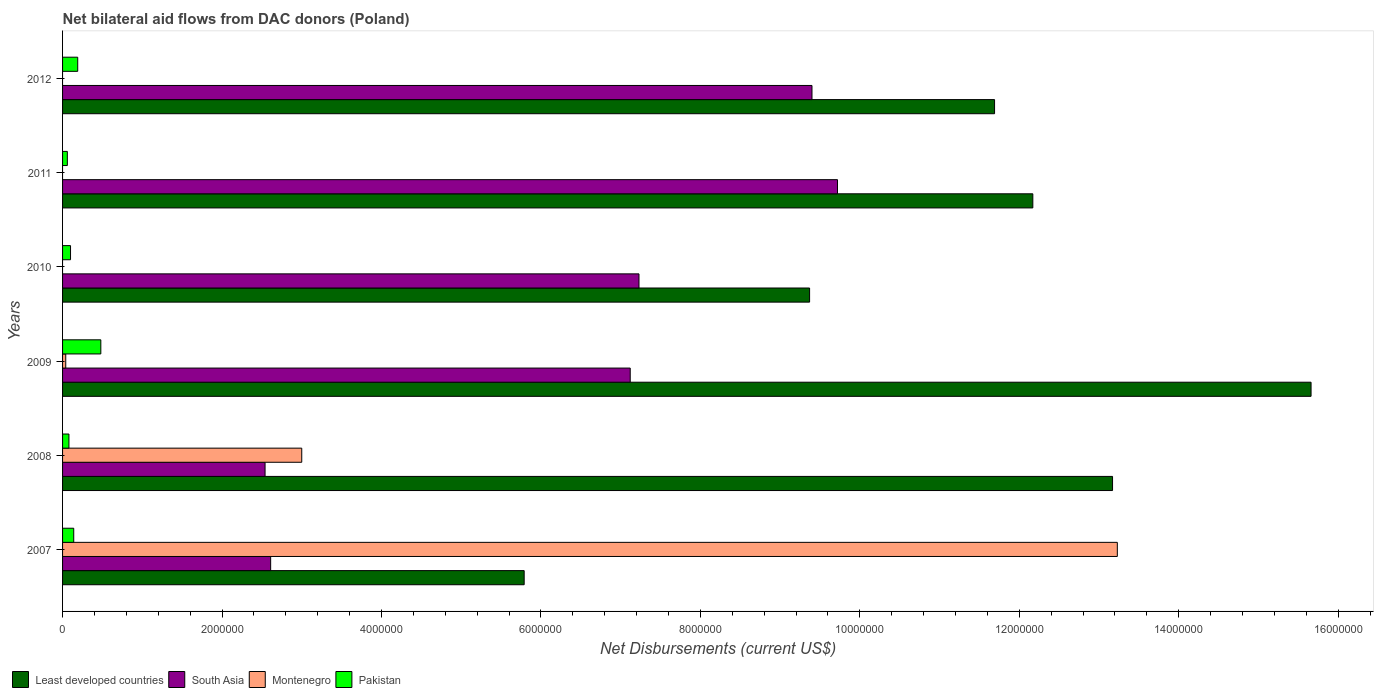Are the number of bars per tick equal to the number of legend labels?
Offer a terse response. No. Are the number of bars on each tick of the Y-axis equal?
Your response must be concise. No. How many bars are there on the 5th tick from the bottom?
Offer a terse response. 3. What is the net bilateral aid flows in Least developed countries in 2010?
Offer a terse response. 9.37e+06. Across all years, what is the maximum net bilateral aid flows in South Asia?
Make the answer very short. 9.72e+06. What is the total net bilateral aid flows in Pakistan in the graph?
Your answer should be very brief. 1.05e+06. What is the difference between the net bilateral aid flows in Least developed countries in 2008 and that in 2009?
Offer a terse response. -2.49e+06. What is the difference between the net bilateral aid flows in Montenegro in 2011 and the net bilateral aid flows in Pakistan in 2012?
Your answer should be compact. -1.90e+05. What is the average net bilateral aid flows in Montenegro per year?
Give a very brief answer. 2.71e+06. In the year 2008, what is the difference between the net bilateral aid flows in Pakistan and net bilateral aid flows in South Asia?
Give a very brief answer. -2.46e+06. Is the difference between the net bilateral aid flows in Pakistan in 2008 and 2009 greater than the difference between the net bilateral aid flows in South Asia in 2008 and 2009?
Ensure brevity in your answer.  Yes. What is the difference between the highest and the second highest net bilateral aid flows in Least developed countries?
Keep it short and to the point. 2.49e+06. What is the difference between the highest and the lowest net bilateral aid flows in Pakistan?
Provide a succinct answer. 4.20e+05. In how many years, is the net bilateral aid flows in Least developed countries greater than the average net bilateral aid flows in Least developed countries taken over all years?
Ensure brevity in your answer.  4. Is it the case that in every year, the sum of the net bilateral aid flows in Montenegro and net bilateral aid flows in Least developed countries is greater than the net bilateral aid flows in Pakistan?
Your answer should be compact. Yes. Are all the bars in the graph horizontal?
Give a very brief answer. Yes. How many years are there in the graph?
Your answer should be very brief. 6. What is the difference between two consecutive major ticks on the X-axis?
Your answer should be very brief. 2.00e+06. Are the values on the major ticks of X-axis written in scientific E-notation?
Ensure brevity in your answer.  No. Where does the legend appear in the graph?
Keep it short and to the point. Bottom left. How many legend labels are there?
Give a very brief answer. 4. What is the title of the graph?
Ensure brevity in your answer.  Net bilateral aid flows from DAC donors (Poland). What is the label or title of the X-axis?
Provide a succinct answer. Net Disbursements (current US$). What is the Net Disbursements (current US$) of Least developed countries in 2007?
Provide a short and direct response. 5.79e+06. What is the Net Disbursements (current US$) in South Asia in 2007?
Make the answer very short. 2.61e+06. What is the Net Disbursements (current US$) in Montenegro in 2007?
Your response must be concise. 1.32e+07. What is the Net Disbursements (current US$) of Pakistan in 2007?
Provide a short and direct response. 1.40e+05. What is the Net Disbursements (current US$) of Least developed countries in 2008?
Provide a short and direct response. 1.32e+07. What is the Net Disbursements (current US$) in South Asia in 2008?
Offer a very short reply. 2.54e+06. What is the Net Disbursements (current US$) in Least developed countries in 2009?
Provide a succinct answer. 1.57e+07. What is the Net Disbursements (current US$) in South Asia in 2009?
Keep it short and to the point. 7.12e+06. What is the Net Disbursements (current US$) of Least developed countries in 2010?
Keep it short and to the point. 9.37e+06. What is the Net Disbursements (current US$) of South Asia in 2010?
Keep it short and to the point. 7.23e+06. What is the Net Disbursements (current US$) in Montenegro in 2010?
Your response must be concise. 0. What is the Net Disbursements (current US$) in Pakistan in 2010?
Provide a succinct answer. 1.00e+05. What is the Net Disbursements (current US$) of Least developed countries in 2011?
Provide a short and direct response. 1.22e+07. What is the Net Disbursements (current US$) of South Asia in 2011?
Ensure brevity in your answer.  9.72e+06. What is the Net Disbursements (current US$) of Montenegro in 2011?
Provide a succinct answer. 0. What is the Net Disbursements (current US$) in Pakistan in 2011?
Provide a succinct answer. 6.00e+04. What is the Net Disbursements (current US$) of Least developed countries in 2012?
Keep it short and to the point. 1.17e+07. What is the Net Disbursements (current US$) in South Asia in 2012?
Your response must be concise. 9.40e+06. What is the Net Disbursements (current US$) in Montenegro in 2012?
Give a very brief answer. 0. Across all years, what is the maximum Net Disbursements (current US$) in Least developed countries?
Provide a succinct answer. 1.57e+07. Across all years, what is the maximum Net Disbursements (current US$) in South Asia?
Your response must be concise. 9.72e+06. Across all years, what is the maximum Net Disbursements (current US$) of Montenegro?
Offer a very short reply. 1.32e+07. Across all years, what is the maximum Net Disbursements (current US$) of Pakistan?
Your answer should be compact. 4.80e+05. Across all years, what is the minimum Net Disbursements (current US$) in Least developed countries?
Keep it short and to the point. 5.79e+06. Across all years, what is the minimum Net Disbursements (current US$) of South Asia?
Your answer should be very brief. 2.54e+06. Across all years, what is the minimum Net Disbursements (current US$) in Montenegro?
Make the answer very short. 0. What is the total Net Disbursements (current US$) of Least developed countries in the graph?
Your response must be concise. 6.78e+07. What is the total Net Disbursements (current US$) in South Asia in the graph?
Provide a short and direct response. 3.86e+07. What is the total Net Disbursements (current US$) of Montenegro in the graph?
Your answer should be compact. 1.63e+07. What is the total Net Disbursements (current US$) of Pakistan in the graph?
Your answer should be very brief. 1.05e+06. What is the difference between the Net Disbursements (current US$) of Least developed countries in 2007 and that in 2008?
Offer a very short reply. -7.38e+06. What is the difference between the Net Disbursements (current US$) of South Asia in 2007 and that in 2008?
Provide a succinct answer. 7.00e+04. What is the difference between the Net Disbursements (current US$) in Montenegro in 2007 and that in 2008?
Make the answer very short. 1.02e+07. What is the difference between the Net Disbursements (current US$) of Least developed countries in 2007 and that in 2009?
Provide a succinct answer. -9.87e+06. What is the difference between the Net Disbursements (current US$) in South Asia in 2007 and that in 2009?
Keep it short and to the point. -4.51e+06. What is the difference between the Net Disbursements (current US$) in Montenegro in 2007 and that in 2009?
Your answer should be very brief. 1.32e+07. What is the difference between the Net Disbursements (current US$) in Least developed countries in 2007 and that in 2010?
Your answer should be very brief. -3.58e+06. What is the difference between the Net Disbursements (current US$) of South Asia in 2007 and that in 2010?
Give a very brief answer. -4.62e+06. What is the difference between the Net Disbursements (current US$) in Pakistan in 2007 and that in 2010?
Provide a succinct answer. 4.00e+04. What is the difference between the Net Disbursements (current US$) in Least developed countries in 2007 and that in 2011?
Ensure brevity in your answer.  -6.38e+06. What is the difference between the Net Disbursements (current US$) in South Asia in 2007 and that in 2011?
Make the answer very short. -7.11e+06. What is the difference between the Net Disbursements (current US$) of Pakistan in 2007 and that in 2011?
Give a very brief answer. 8.00e+04. What is the difference between the Net Disbursements (current US$) of Least developed countries in 2007 and that in 2012?
Make the answer very short. -5.90e+06. What is the difference between the Net Disbursements (current US$) in South Asia in 2007 and that in 2012?
Ensure brevity in your answer.  -6.79e+06. What is the difference between the Net Disbursements (current US$) of Pakistan in 2007 and that in 2012?
Your answer should be very brief. -5.00e+04. What is the difference between the Net Disbursements (current US$) of Least developed countries in 2008 and that in 2009?
Your response must be concise. -2.49e+06. What is the difference between the Net Disbursements (current US$) of South Asia in 2008 and that in 2009?
Provide a succinct answer. -4.58e+06. What is the difference between the Net Disbursements (current US$) of Montenegro in 2008 and that in 2009?
Your response must be concise. 2.96e+06. What is the difference between the Net Disbursements (current US$) of Pakistan in 2008 and that in 2009?
Offer a very short reply. -4.00e+05. What is the difference between the Net Disbursements (current US$) of Least developed countries in 2008 and that in 2010?
Your response must be concise. 3.80e+06. What is the difference between the Net Disbursements (current US$) in South Asia in 2008 and that in 2010?
Make the answer very short. -4.69e+06. What is the difference between the Net Disbursements (current US$) of Least developed countries in 2008 and that in 2011?
Ensure brevity in your answer.  1.00e+06. What is the difference between the Net Disbursements (current US$) in South Asia in 2008 and that in 2011?
Make the answer very short. -7.18e+06. What is the difference between the Net Disbursements (current US$) in Pakistan in 2008 and that in 2011?
Offer a terse response. 2.00e+04. What is the difference between the Net Disbursements (current US$) in Least developed countries in 2008 and that in 2012?
Offer a terse response. 1.48e+06. What is the difference between the Net Disbursements (current US$) in South Asia in 2008 and that in 2012?
Offer a terse response. -6.86e+06. What is the difference between the Net Disbursements (current US$) in Least developed countries in 2009 and that in 2010?
Your answer should be compact. 6.29e+06. What is the difference between the Net Disbursements (current US$) in South Asia in 2009 and that in 2010?
Offer a very short reply. -1.10e+05. What is the difference between the Net Disbursements (current US$) in Pakistan in 2009 and that in 2010?
Offer a terse response. 3.80e+05. What is the difference between the Net Disbursements (current US$) of Least developed countries in 2009 and that in 2011?
Your answer should be compact. 3.49e+06. What is the difference between the Net Disbursements (current US$) in South Asia in 2009 and that in 2011?
Make the answer very short. -2.60e+06. What is the difference between the Net Disbursements (current US$) of Pakistan in 2009 and that in 2011?
Provide a succinct answer. 4.20e+05. What is the difference between the Net Disbursements (current US$) of Least developed countries in 2009 and that in 2012?
Make the answer very short. 3.97e+06. What is the difference between the Net Disbursements (current US$) of South Asia in 2009 and that in 2012?
Give a very brief answer. -2.28e+06. What is the difference between the Net Disbursements (current US$) in Least developed countries in 2010 and that in 2011?
Make the answer very short. -2.80e+06. What is the difference between the Net Disbursements (current US$) of South Asia in 2010 and that in 2011?
Give a very brief answer. -2.49e+06. What is the difference between the Net Disbursements (current US$) of Least developed countries in 2010 and that in 2012?
Offer a very short reply. -2.32e+06. What is the difference between the Net Disbursements (current US$) in South Asia in 2010 and that in 2012?
Make the answer very short. -2.17e+06. What is the difference between the Net Disbursements (current US$) of Pakistan in 2010 and that in 2012?
Provide a short and direct response. -9.00e+04. What is the difference between the Net Disbursements (current US$) of Least developed countries in 2011 and that in 2012?
Provide a short and direct response. 4.80e+05. What is the difference between the Net Disbursements (current US$) in South Asia in 2011 and that in 2012?
Make the answer very short. 3.20e+05. What is the difference between the Net Disbursements (current US$) of Least developed countries in 2007 and the Net Disbursements (current US$) of South Asia in 2008?
Your answer should be compact. 3.25e+06. What is the difference between the Net Disbursements (current US$) in Least developed countries in 2007 and the Net Disbursements (current US$) in Montenegro in 2008?
Keep it short and to the point. 2.79e+06. What is the difference between the Net Disbursements (current US$) in Least developed countries in 2007 and the Net Disbursements (current US$) in Pakistan in 2008?
Keep it short and to the point. 5.71e+06. What is the difference between the Net Disbursements (current US$) in South Asia in 2007 and the Net Disbursements (current US$) in Montenegro in 2008?
Make the answer very short. -3.90e+05. What is the difference between the Net Disbursements (current US$) of South Asia in 2007 and the Net Disbursements (current US$) of Pakistan in 2008?
Provide a succinct answer. 2.53e+06. What is the difference between the Net Disbursements (current US$) in Montenegro in 2007 and the Net Disbursements (current US$) in Pakistan in 2008?
Offer a very short reply. 1.32e+07. What is the difference between the Net Disbursements (current US$) in Least developed countries in 2007 and the Net Disbursements (current US$) in South Asia in 2009?
Provide a succinct answer. -1.33e+06. What is the difference between the Net Disbursements (current US$) in Least developed countries in 2007 and the Net Disbursements (current US$) in Montenegro in 2009?
Ensure brevity in your answer.  5.75e+06. What is the difference between the Net Disbursements (current US$) in Least developed countries in 2007 and the Net Disbursements (current US$) in Pakistan in 2009?
Ensure brevity in your answer.  5.31e+06. What is the difference between the Net Disbursements (current US$) of South Asia in 2007 and the Net Disbursements (current US$) of Montenegro in 2009?
Provide a short and direct response. 2.57e+06. What is the difference between the Net Disbursements (current US$) in South Asia in 2007 and the Net Disbursements (current US$) in Pakistan in 2009?
Give a very brief answer. 2.13e+06. What is the difference between the Net Disbursements (current US$) in Montenegro in 2007 and the Net Disbursements (current US$) in Pakistan in 2009?
Make the answer very short. 1.28e+07. What is the difference between the Net Disbursements (current US$) in Least developed countries in 2007 and the Net Disbursements (current US$) in South Asia in 2010?
Offer a terse response. -1.44e+06. What is the difference between the Net Disbursements (current US$) of Least developed countries in 2007 and the Net Disbursements (current US$) of Pakistan in 2010?
Keep it short and to the point. 5.69e+06. What is the difference between the Net Disbursements (current US$) in South Asia in 2007 and the Net Disbursements (current US$) in Pakistan in 2010?
Your answer should be very brief. 2.51e+06. What is the difference between the Net Disbursements (current US$) in Montenegro in 2007 and the Net Disbursements (current US$) in Pakistan in 2010?
Ensure brevity in your answer.  1.31e+07. What is the difference between the Net Disbursements (current US$) in Least developed countries in 2007 and the Net Disbursements (current US$) in South Asia in 2011?
Make the answer very short. -3.93e+06. What is the difference between the Net Disbursements (current US$) of Least developed countries in 2007 and the Net Disbursements (current US$) of Pakistan in 2011?
Offer a terse response. 5.73e+06. What is the difference between the Net Disbursements (current US$) in South Asia in 2007 and the Net Disbursements (current US$) in Pakistan in 2011?
Offer a terse response. 2.55e+06. What is the difference between the Net Disbursements (current US$) in Montenegro in 2007 and the Net Disbursements (current US$) in Pakistan in 2011?
Make the answer very short. 1.32e+07. What is the difference between the Net Disbursements (current US$) in Least developed countries in 2007 and the Net Disbursements (current US$) in South Asia in 2012?
Provide a short and direct response. -3.61e+06. What is the difference between the Net Disbursements (current US$) of Least developed countries in 2007 and the Net Disbursements (current US$) of Pakistan in 2012?
Ensure brevity in your answer.  5.60e+06. What is the difference between the Net Disbursements (current US$) of South Asia in 2007 and the Net Disbursements (current US$) of Pakistan in 2012?
Keep it short and to the point. 2.42e+06. What is the difference between the Net Disbursements (current US$) in Montenegro in 2007 and the Net Disbursements (current US$) in Pakistan in 2012?
Offer a very short reply. 1.30e+07. What is the difference between the Net Disbursements (current US$) of Least developed countries in 2008 and the Net Disbursements (current US$) of South Asia in 2009?
Your answer should be very brief. 6.05e+06. What is the difference between the Net Disbursements (current US$) in Least developed countries in 2008 and the Net Disbursements (current US$) in Montenegro in 2009?
Provide a succinct answer. 1.31e+07. What is the difference between the Net Disbursements (current US$) of Least developed countries in 2008 and the Net Disbursements (current US$) of Pakistan in 2009?
Make the answer very short. 1.27e+07. What is the difference between the Net Disbursements (current US$) in South Asia in 2008 and the Net Disbursements (current US$) in Montenegro in 2009?
Your answer should be compact. 2.50e+06. What is the difference between the Net Disbursements (current US$) in South Asia in 2008 and the Net Disbursements (current US$) in Pakistan in 2009?
Your response must be concise. 2.06e+06. What is the difference between the Net Disbursements (current US$) of Montenegro in 2008 and the Net Disbursements (current US$) of Pakistan in 2009?
Ensure brevity in your answer.  2.52e+06. What is the difference between the Net Disbursements (current US$) in Least developed countries in 2008 and the Net Disbursements (current US$) in South Asia in 2010?
Offer a very short reply. 5.94e+06. What is the difference between the Net Disbursements (current US$) of Least developed countries in 2008 and the Net Disbursements (current US$) of Pakistan in 2010?
Keep it short and to the point. 1.31e+07. What is the difference between the Net Disbursements (current US$) of South Asia in 2008 and the Net Disbursements (current US$) of Pakistan in 2010?
Your answer should be very brief. 2.44e+06. What is the difference between the Net Disbursements (current US$) in Montenegro in 2008 and the Net Disbursements (current US$) in Pakistan in 2010?
Ensure brevity in your answer.  2.90e+06. What is the difference between the Net Disbursements (current US$) of Least developed countries in 2008 and the Net Disbursements (current US$) of South Asia in 2011?
Keep it short and to the point. 3.45e+06. What is the difference between the Net Disbursements (current US$) in Least developed countries in 2008 and the Net Disbursements (current US$) in Pakistan in 2011?
Provide a succinct answer. 1.31e+07. What is the difference between the Net Disbursements (current US$) of South Asia in 2008 and the Net Disbursements (current US$) of Pakistan in 2011?
Offer a terse response. 2.48e+06. What is the difference between the Net Disbursements (current US$) in Montenegro in 2008 and the Net Disbursements (current US$) in Pakistan in 2011?
Your answer should be very brief. 2.94e+06. What is the difference between the Net Disbursements (current US$) of Least developed countries in 2008 and the Net Disbursements (current US$) of South Asia in 2012?
Provide a succinct answer. 3.77e+06. What is the difference between the Net Disbursements (current US$) in Least developed countries in 2008 and the Net Disbursements (current US$) in Pakistan in 2012?
Make the answer very short. 1.30e+07. What is the difference between the Net Disbursements (current US$) of South Asia in 2008 and the Net Disbursements (current US$) of Pakistan in 2012?
Keep it short and to the point. 2.35e+06. What is the difference between the Net Disbursements (current US$) of Montenegro in 2008 and the Net Disbursements (current US$) of Pakistan in 2012?
Your answer should be very brief. 2.81e+06. What is the difference between the Net Disbursements (current US$) in Least developed countries in 2009 and the Net Disbursements (current US$) in South Asia in 2010?
Your response must be concise. 8.43e+06. What is the difference between the Net Disbursements (current US$) in Least developed countries in 2009 and the Net Disbursements (current US$) in Pakistan in 2010?
Your response must be concise. 1.56e+07. What is the difference between the Net Disbursements (current US$) of South Asia in 2009 and the Net Disbursements (current US$) of Pakistan in 2010?
Your answer should be compact. 7.02e+06. What is the difference between the Net Disbursements (current US$) of Least developed countries in 2009 and the Net Disbursements (current US$) of South Asia in 2011?
Your response must be concise. 5.94e+06. What is the difference between the Net Disbursements (current US$) in Least developed countries in 2009 and the Net Disbursements (current US$) in Pakistan in 2011?
Keep it short and to the point. 1.56e+07. What is the difference between the Net Disbursements (current US$) in South Asia in 2009 and the Net Disbursements (current US$) in Pakistan in 2011?
Provide a short and direct response. 7.06e+06. What is the difference between the Net Disbursements (current US$) in Least developed countries in 2009 and the Net Disbursements (current US$) in South Asia in 2012?
Offer a terse response. 6.26e+06. What is the difference between the Net Disbursements (current US$) of Least developed countries in 2009 and the Net Disbursements (current US$) of Pakistan in 2012?
Provide a short and direct response. 1.55e+07. What is the difference between the Net Disbursements (current US$) of South Asia in 2009 and the Net Disbursements (current US$) of Pakistan in 2012?
Offer a very short reply. 6.93e+06. What is the difference between the Net Disbursements (current US$) of Least developed countries in 2010 and the Net Disbursements (current US$) of South Asia in 2011?
Make the answer very short. -3.50e+05. What is the difference between the Net Disbursements (current US$) in Least developed countries in 2010 and the Net Disbursements (current US$) in Pakistan in 2011?
Make the answer very short. 9.31e+06. What is the difference between the Net Disbursements (current US$) in South Asia in 2010 and the Net Disbursements (current US$) in Pakistan in 2011?
Give a very brief answer. 7.17e+06. What is the difference between the Net Disbursements (current US$) of Least developed countries in 2010 and the Net Disbursements (current US$) of South Asia in 2012?
Provide a succinct answer. -3.00e+04. What is the difference between the Net Disbursements (current US$) of Least developed countries in 2010 and the Net Disbursements (current US$) of Pakistan in 2012?
Make the answer very short. 9.18e+06. What is the difference between the Net Disbursements (current US$) of South Asia in 2010 and the Net Disbursements (current US$) of Pakistan in 2012?
Provide a short and direct response. 7.04e+06. What is the difference between the Net Disbursements (current US$) in Least developed countries in 2011 and the Net Disbursements (current US$) in South Asia in 2012?
Give a very brief answer. 2.77e+06. What is the difference between the Net Disbursements (current US$) of Least developed countries in 2011 and the Net Disbursements (current US$) of Pakistan in 2012?
Keep it short and to the point. 1.20e+07. What is the difference between the Net Disbursements (current US$) of South Asia in 2011 and the Net Disbursements (current US$) of Pakistan in 2012?
Your answer should be very brief. 9.53e+06. What is the average Net Disbursements (current US$) of Least developed countries per year?
Give a very brief answer. 1.13e+07. What is the average Net Disbursements (current US$) in South Asia per year?
Provide a short and direct response. 6.44e+06. What is the average Net Disbursements (current US$) in Montenegro per year?
Provide a short and direct response. 2.71e+06. What is the average Net Disbursements (current US$) in Pakistan per year?
Provide a short and direct response. 1.75e+05. In the year 2007, what is the difference between the Net Disbursements (current US$) in Least developed countries and Net Disbursements (current US$) in South Asia?
Your answer should be very brief. 3.18e+06. In the year 2007, what is the difference between the Net Disbursements (current US$) of Least developed countries and Net Disbursements (current US$) of Montenegro?
Your answer should be compact. -7.44e+06. In the year 2007, what is the difference between the Net Disbursements (current US$) in Least developed countries and Net Disbursements (current US$) in Pakistan?
Provide a short and direct response. 5.65e+06. In the year 2007, what is the difference between the Net Disbursements (current US$) of South Asia and Net Disbursements (current US$) of Montenegro?
Your answer should be compact. -1.06e+07. In the year 2007, what is the difference between the Net Disbursements (current US$) of South Asia and Net Disbursements (current US$) of Pakistan?
Give a very brief answer. 2.47e+06. In the year 2007, what is the difference between the Net Disbursements (current US$) of Montenegro and Net Disbursements (current US$) of Pakistan?
Your response must be concise. 1.31e+07. In the year 2008, what is the difference between the Net Disbursements (current US$) in Least developed countries and Net Disbursements (current US$) in South Asia?
Provide a succinct answer. 1.06e+07. In the year 2008, what is the difference between the Net Disbursements (current US$) of Least developed countries and Net Disbursements (current US$) of Montenegro?
Make the answer very short. 1.02e+07. In the year 2008, what is the difference between the Net Disbursements (current US$) of Least developed countries and Net Disbursements (current US$) of Pakistan?
Your response must be concise. 1.31e+07. In the year 2008, what is the difference between the Net Disbursements (current US$) of South Asia and Net Disbursements (current US$) of Montenegro?
Make the answer very short. -4.60e+05. In the year 2008, what is the difference between the Net Disbursements (current US$) of South Asia and Net Disbursements (current US$) of Pakistan?
Provide a succinct answer. 2.46e+06. In the year 2008, what is the difference between the Net Disbursements (current US$) of Montenegro and Net Disbursements (current US$) of Pakistan?
Your answer should be compact. 2.92e+06. In the year 2009, what is the difference between the Net Disbursements (current US$) of Least developed countries and Net Disbursements (current US$) of South Asia?
Make the answer very short. 8.54e+06. In the year 2009, what is the difference between the Net Disbursements (current US$) of Least developed countries and Net Disbursements (current US$) of Montenegro?
Provide a short and direct response. 1.56e+07. In the year 2009, what is the difference between the Net Disbursements (current US$) in Least developed countries and Net Disbursements (current US$) in Pakistan?
Provide a succinct answer. 1.52e+07. In the year 2009, what is the difference between the Net Disbursements (current US$) of South Asia and Net Disbursements (current US$) of Montenegro?
Keep it short and to the point. 7.08e+06. In the year 2009, what is the difference between the Net Disbursements (current US$) of South Asia and Net Disbursements (current US$) of Pakistan?
Make the answer very short. 6.64e+06. In the year 2009, what is the difference between the Net Disbursements (current US$) in Montenegro and Net Disbursements (current US$) in Pakistan?
Your answer should be compact. -4.40e+05. In the year 2010, what is the difference between the Net Disbursements (current US$) of Least developed countries and Net Disbursements (current US$) of South Asia?
Offer a terse response. 2.14e+06. In the year 2010, what is the difference between the Net Disbursements (current US$) of Least developed countries and Net Disbursements (current US$) of Pakistan?
Ensure brevity in your answer.  9.27e+06. In the year 2010, what is the difference between the Net Disbursements (current US$) in South Asia and Net Disbursements (current US$) in Pakistan?
Offer a terse response. 7.13e+06. In the year 2011, what is the difference between the Net Disbursements (current US$) in Least developed countries and Net Disbursements (current US$) in South Asia?
Your answer should be very brief. 2.45e+06. In the year 2011, what is the difference between the Net Disbursements (current US$) of Least developed countries and Net Disbursements (current US$) of Pakistan?
Your answer should be very brief. 1.21e+07. In the year 2011, what is the difference between the Net Disbursements (current US$) in South Asia and Net Disbursements (current US$) in Pakistan?
Give a very brief answer. 9.66e+06. In the year 2012, what is the difference between the Net Disbursements (current US$) of Least developed countries and Net Disbursements (current US$) of South Asia?
Provide a short and direct response. 2.29e+06. In the year 2012, what is the difference between the Net Disbursements (current US$) of Least developed countries and Net Disbursements (current US$) of Pakistan?
Give a very brief answer. 1.15e+07. In the year 2012, what is the difference between the Net Disbursements (current US$) in South Asia and Net Disbursements (current US$) in Pakistan?
Your response must be concise. 9.21e+06. What is the ratio of the Net Disbursements (current US$) of Least developed countries in 2007 to that in 2008?
Offer a very short reply. 0.44. What is the ratio of the Net Disbursements (current US$) in South Asia in 2007 to that in 2008?
Your answer should be very brief. 1.03. What is the ratio of the Net Disbursements (current US$) in Montenegro in 2007 to that in 2008?
Your answer should be very brief. 4.41. What is the ratio of the Net Disbursements (current US$) of Pakistan in 2007 to that in 2008?
Make the answer very short. 1.75. What is the ratio of the Net Disbursements (current US$) in Least developed countries in 2007 to that in 2009?
Ensure brevity in your answer.  0.37. What is the ratio of the Net Disbursements (current US$) of South Asia in 2007 to that in 2009?
Make the answer very short. 0.37. What is the ratio of the Net Disbursements (current US$) of Montenegro in 2007 to that in 2009?
Ensure brevity in your answer.  330.75. What is the ratio of the Net Disbursements (current US$) in Pakistan in 2007 to that in 2009?
Keep it short and to the point. 0.29. What is the ratio of the Net Disbursements (current US$) in Least developed countries in 2007 to that in 2010?
Ensure brevity in your answer.  0.62. What is the ratio of the Net Disbursements (current US$) in South Asia in 2007 to that in 2010?
Your answer should be compact. 0.36. What is the ratio of the Net Disbursements (current US$) of Least developed countries in 2007 to that in 2011?
Offer a terse response. 0.48. What is the ratio of the Net Disbursements (current US$) of South Asia in 2007 to that in 2011?
Offer a terse response. 0.27. What is the ratio of the Net Disbursements (current US$) in Pakistan in 2007 to that in 2011?
Make the answer very short. 2.33. What is the ratio of the Net Disbursements (current US$) of Least developed countries in 2007 to that in 2012?
Provide a succinct answer. 0.5. What is the ratio of the Net Disbursements (current US$) in South Asia in 2007 to that in 2012?
Keep it short and to the point. 0.28. What is the ratio of the Net Disbursements (current US$) of Pakistan in 2007 to that in 2012?
Provide a succinct answer. 0.74. What is the ratio of the Net Disbursements (current US$) in Least developed countries in 2008 to that in 2009?
Ensure brevity in your answer.  0.84. What is the ratio of the Net Disbursements (current US$) of South Asia in 2008 to that in 2009?
Keep it short and to the point. 0.36. What is the ratio of the Net Disbursements (current US$) in Montenegro in 2008 to that in 2009?
Provide a succinct answer. 75. What is the ratio of the Net Disbursements (current US$) of Pakistan in 2008 to that in 2009?
Keep it short and to the point. 0.17. What is the ratio of the Net Disbursements (current US$) of Least developed countries in 2008 to that in 2010?
Ensure brevity in your answer.  1.41. What is the ratio of the Net Disbursements (current US$) of South Asia in 2008 to that in 2010?
Provide a short and direct response. 0.35. What is the ratio of the Net Disbursements (current US$) of Least developed countries in 2008 to that in 2011?
Provide a short and direct response. 1.08. What is the ratio of the Net Disbursements (current US$) in South Asia in 2008 to that in 2011?
Provide a succinct answer. 0.26. What is the ratio of the Net Disbursements (current US$) in Least developed countries in 2008 to that in 2012?
Make the answer very short. 1.13. What is the ratio of the Net Disbursements (current US$) in South Asia in 2008 to that in 2012?
Your response must be concise. 0.27. What is the ratio of the Net Disbursements (current US$) of Pakistan in 2008 to that in 2012?
Provide a short and direct response. 0.42. What is the ratio of the Net Disbursements (current US$) of Least developed countries in 2009 to that in 2010?
Ensure brevity in your answer.  1.67. What is the ratio of the Net Disbursements (current US$) in Pakistan in 2009 to that in 2010?
Make the answer very short. 4.8. What is the ratio of the Net Disbursements (current US$) in Least developed countries in 2009 to that in 2011?
Your answer should be very brief. 1.29. What is the ratio of the Net Disbursements (current US$) in South Asia in 2009 to that in 2011?
Offer a terse response. 0.73. What is the ratio of the Net Disbursements (current US$) of Least developed countries in 2009 to that in 2012?
Ensure brevity in your answer.  1.34. What is the ratio of the Net Disbursements (current US$) in South Asia in 2009 to that in 2012?
Offer a terse response. 0.76. What is the ratio of the Net Disbursements (current US$) of Pakistan in 2009 to that in 2012?
Your answer should be compact. 2.53. What is the ratio of the Net Disbursements (current US$) in Least developed countries in 2010 to that in 2011?
Ensure brevity in your answer.  0.77. What is the ratio of the Net Disbursements (current US$) of South Asia in 2010 to that in 2011?
Your response must be concise. 0.74. What is the ratio of the Net Disbursements (current US$) in Least developed countries in 2010 to that in 2012?
Your answer should be compact. 0.8. What is the ratio of the Net Disbursements (current US$) in South Asia in 2010 to that in 2012?
Give a very brief answer. 0.77. What is the ratio of the Net Disbursements (current US$) of Pakistan in 2010 to that in 2012?
Your response must be concise. 0.53. What is the ratio of the Net Disbursements (current US$) of Least developed countries in 2011 to that in 2012?
Provide a succinct answer. 1.04. What is the ratio of the Net Disbursements (current US$) of South Asia in 2011 to that in 2012?
Your answer should be very brief. 1.03. What is the ratio of the Net Disbursements (current US$) in Pakistan in 2011 to that in 2012?
Provide a short and direct response. 0.32. What is the difference between the highest and the second highest Net Disbursements (current US$) in Least developed countries?
Offer a very short reply. 2.49e+06. What is the difference between the highest and the second highest Net Disbursements (current US$) of Montenegro?
Offer a very short reply. 1.02e+07. What is the difference between the highest and the lowest Net Disbursements (current US$) in Least developed countries?
Your answer should be compact. 9.87e+06. What is the difference between the highest and the lowest Net Disbursements (current US$) of South Asia?
Your answer should be compact. 7.18e+06. What is the difference between the highest and the lowest Net Disbursements (current US$) of Montenegro?
Offer a very short reply. 1.32e+07. What is the difference between the highest and the lowest Net Disbursements (current US$) of Pakistan?
Your answer should be compact. 4.20e+05. 